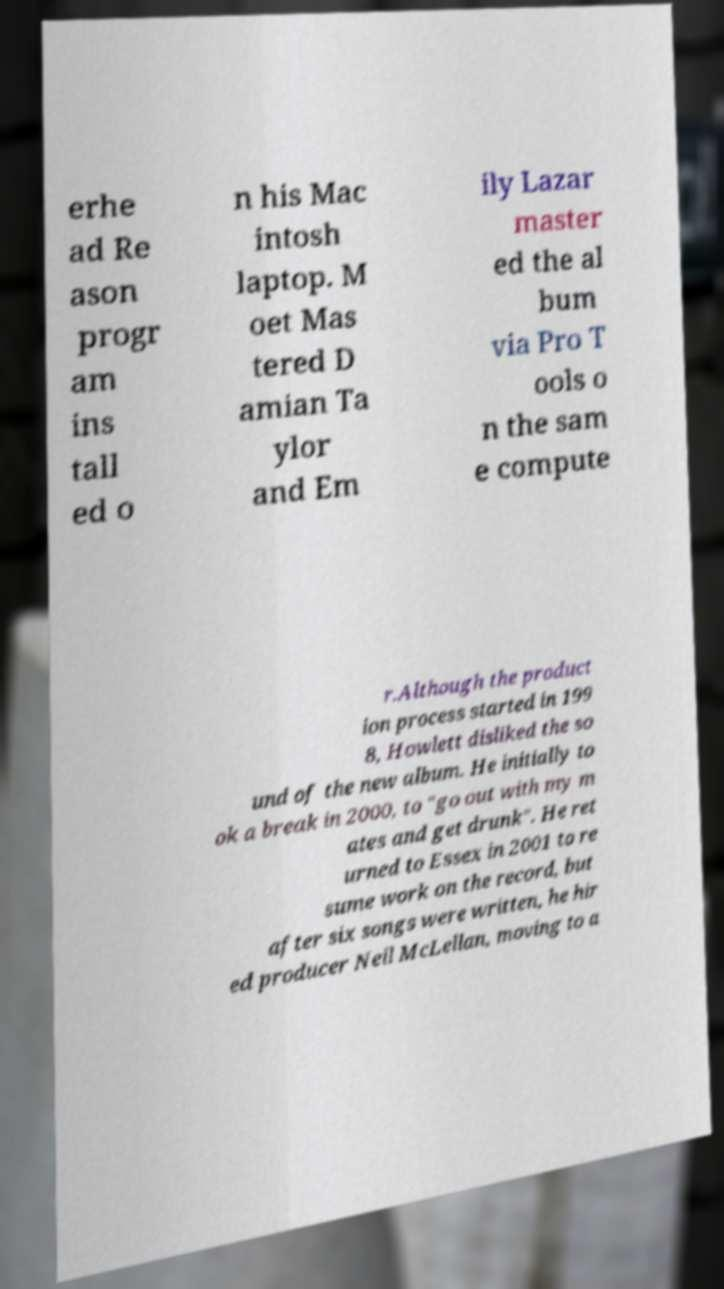What messages or text are displayed in this image? I need them in a readable, typed format. erhe ad Re ason progr am ins tall ed o n his Mac intosh laptop. M oet Mas tered D amian Ta ylor and Em ily Lazar master ed the al bum via Pro T ools o n the sam e compute r.Although the product ion process started in 199 8, Howlett disliked the so und of the new album. He initially to ok a break in 2000, to "go out with my m ates and get drunk". He ret urned to Essex in 2001 to re sume work on the record, but after six songs were written, he hir ed producer Neil McLellan, moving to a 